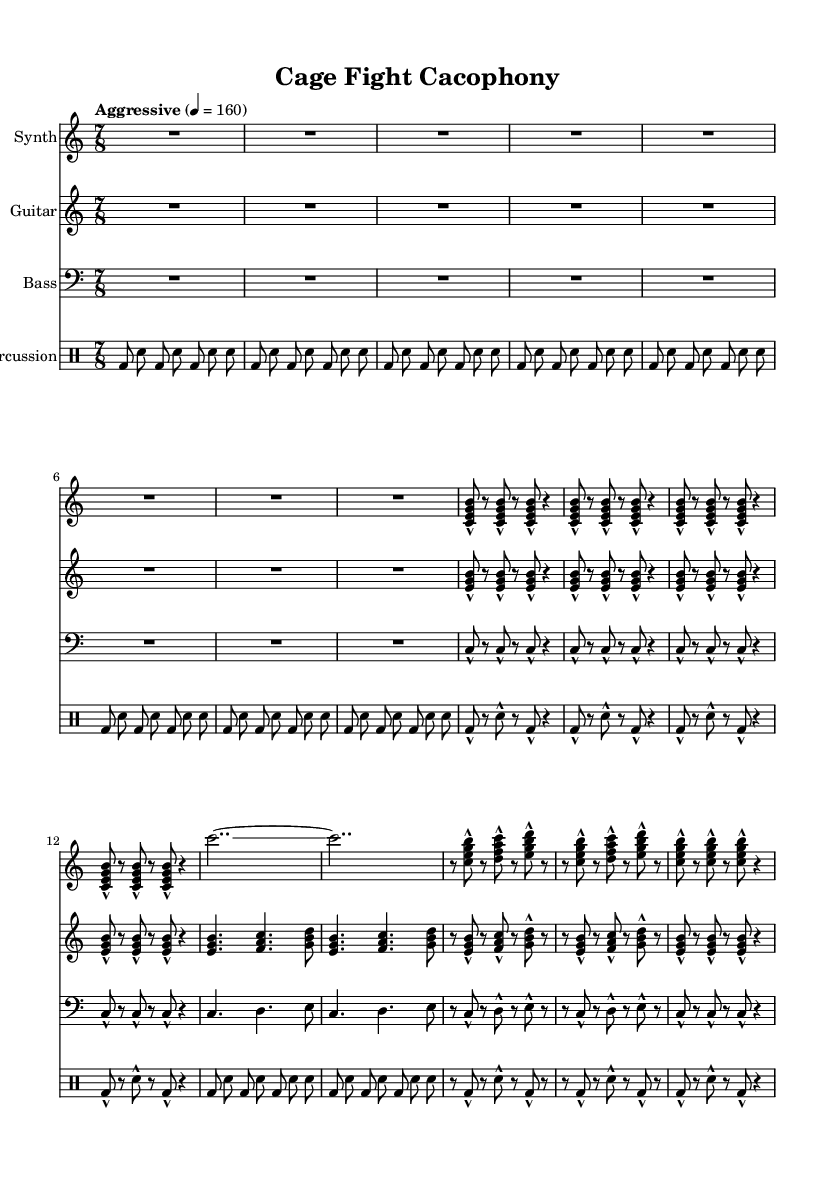What is the time signature of this music? The time signature is indicated at the beginning of the score, showing 7 over 8, which means there are 7 eighth notes in each measure.
Answer: 7/8 What is the tempo marking for this piece? The tempo is specified as "Aggressive," with a metronome setting of 160 beats per minute, indicated at the start of the global section.
Answer: Aggressive, 160 How many measures are in the verse section? The verse section contains a repeated phrase that occurs 4 times, as indicated by the repeat unfold directive within the synthMusic and guitarMusic sections.
Answer: 4 What distinctive musical element is present in the chorus? The chorus includes a glissando, a technique where the pitch slides from one note to another instead of jumping directly, which contributes to the intensity reflecting combat sports.
Answer: Glissando What instruments are used in this score? The score lists four distinct instruments: Synth, Guitar, Bass, and Percussion as indicated in the score layout.
Answer: Synth, Guitar, Bass, Percussion How does the percussion pattern contribute to the sense of urgency? The percussion pattern features a driving rhythm of bass drum and snare hits, creating a compelling and aggressive beat that enhances the sense of urgency associated with combat sports.
Answer: Driving rhythm 